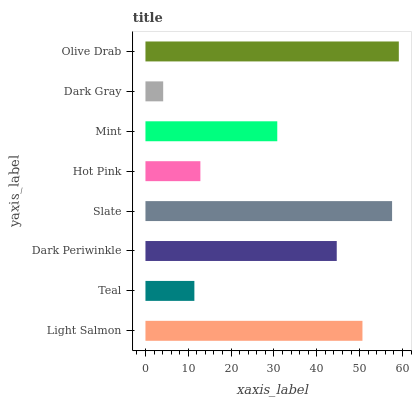Is Dark Gray the minimum?
Answer yes or no. Yes. Is Olive Drab the maximum?
Answer yes or no. Yes. Is Teal the minimum?
Answer yes or no. No. Is Teal the maximum?
Answer yes or no. No. Is Light Salmon greater than Teal?
Answer yes or no. Yes. Is Teal less than Light Salmon?
Answer yes or no. Yes. Is Teal greater than Light Salmon?
Answer yes or no. No. Is Light Salmon less than Teal?
Answer yes or no. No. Is Dark Periwinkle the high median?
Answer yes or no. Yes. Is Mint the low median?
Answer yes or no. Yes. Is Teal the high median?
Answer yes or no. No. Is Light Salmon the low median?
Answer yes or no. No. 